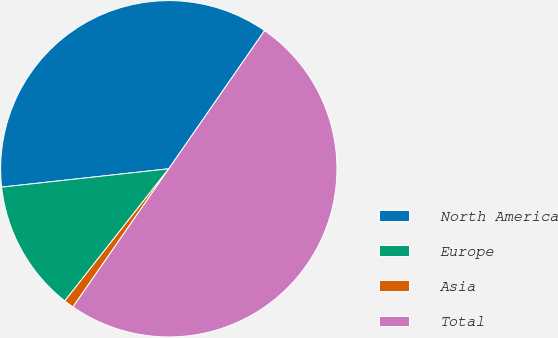Convert chart to OTSL. <chart><loc_0><loc_0><loc_500><loc_500><pie_chart><fcel>North America<fcel>Europe<fcel>Asia<fcel>Total<nl><fcel>36.39%<fcel>12.65%<fcel>0.96%<fcel>50.0%<nl></chart> 